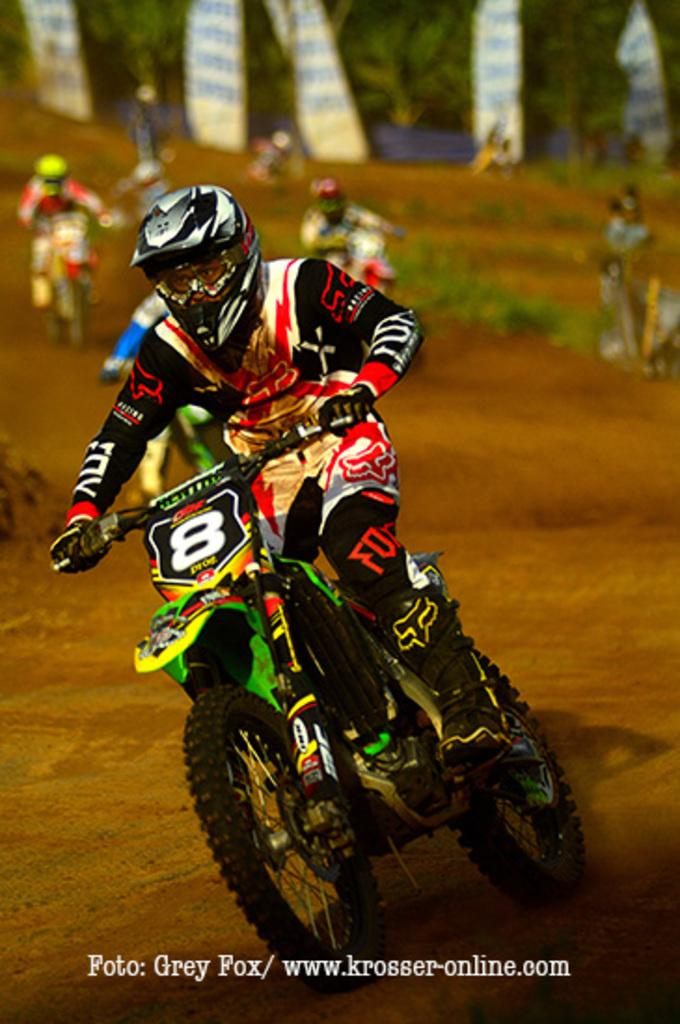What is the main subject of the image? The main subject of the image is a motorbike race. What are the people in the image doing? The people in the image are riding bikes. What safety precaution are the riders taking? The riders are wearing helmets. Is there any text present in the image? Yes, there is text at the bottom of the image. What type of knot is being tied by the riders during the race in the image? There is no knot-tying activity depicted in the image; the riders are focused on racing their motorbikes. What type of pleasure can be seen being experienced by the riders during the race in the image? The image does not show the riders' emotions or experiences of pleasure; it only depicts them racing their motorbikes. 